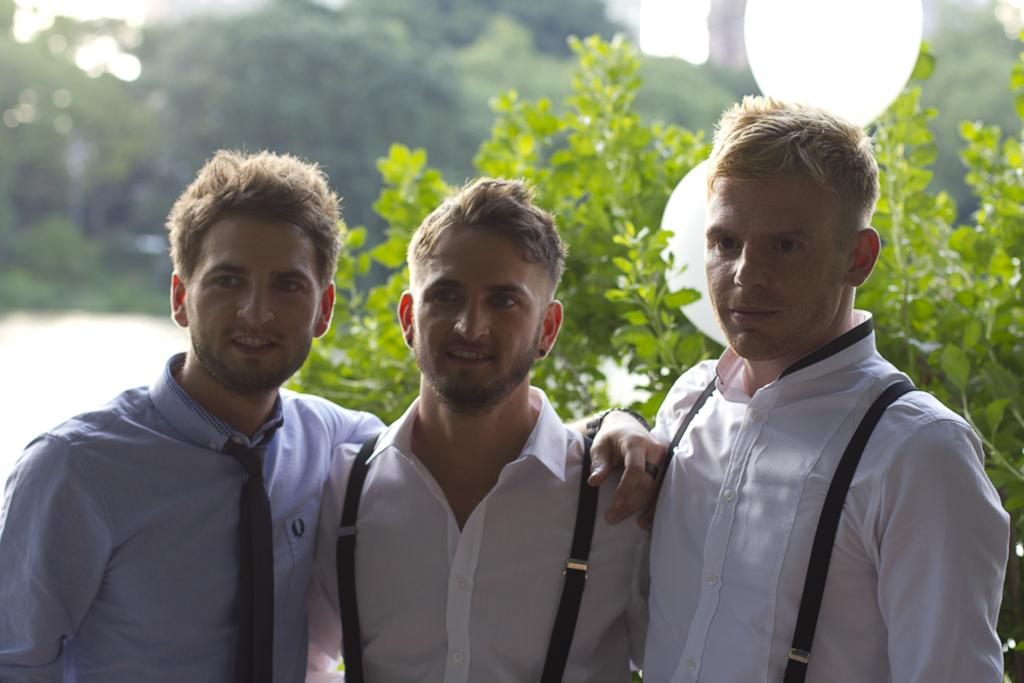Where was the image taken? The image was taken outdoors. What can be seen in the background of the image? There are trees with green leaves in the background. How many boys are in the image? Three boys are standing in the middle of the image. What is the facial expression of the boys? The boys are smiling. What type of glue is being used by the boys in the image? There is no glue present in the image; the boys are simply standing and smiling. Can you tell me what kind of camera was used to take the image? The type of camera used to take the image is not visible or mentioned in the image. 